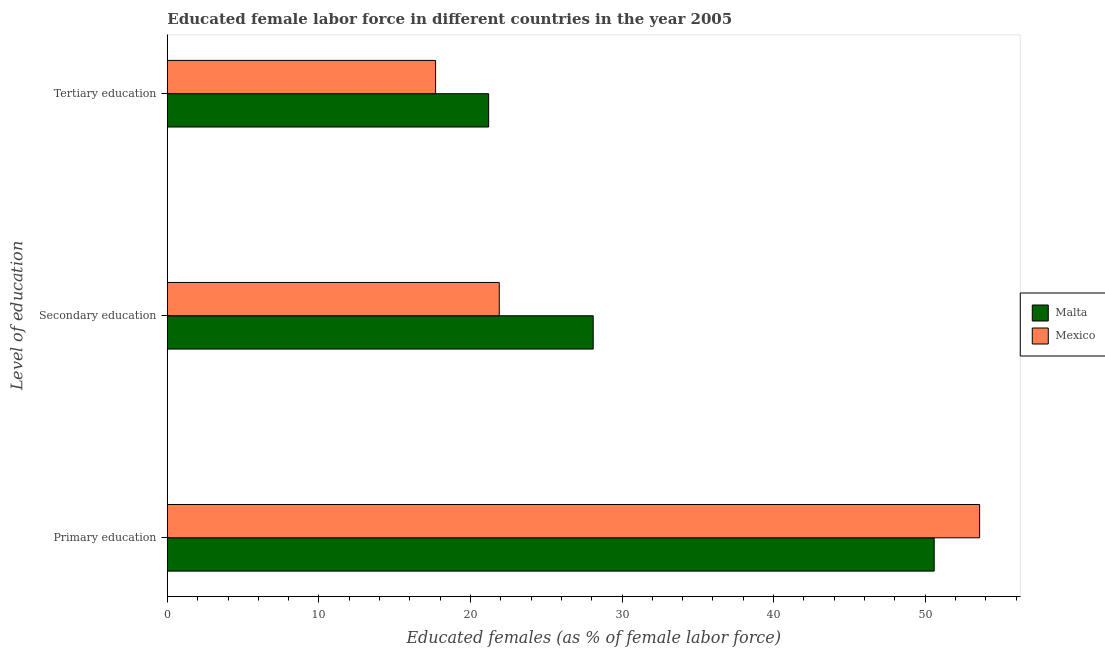How many different coloured bars are there?
Your answer should be compact. 2. Are the number of bars per tick equal to the number of legend labels?
Offer a very short reply. Yes. How many bars are there on the 1st tick from the top?
Your answer should be compact. 2. What is the label of the 1st group of bars from the top?
Your answer should be compact. Tertiary education. What is the percentage of female labor force who received tertiary education in Mexico?
Offer a very short reply. 17.7. Across all countries, what is the maximum percentage of female labor force who received primary education?
Make the answer very short. 53.6. Across all countries, what is the minimum percentage of female labor force who received primary education?
Provide a short and direct response. 50.6. In which country was the percentage of female labor force who received tertiary education maximum?
Provide a succinct answer. Malta. In which country was the percentage of female labor force who received tertiary education minimum?
Give a very brief answer. Mexico. What is the total percentage of female labor force who received tertiary education in the graph?
Your answer should be compact. 38.9. What is the difference between the percentage of female labor force who received secondary education in Mexico and that in Malta?
Your answer should be compact. -6.2. What is the difference between the percentage of female labor force who received secondary education in Mexico and the percentage of female labor force who received primary education in Malta?
Your response must be concise. -28.7. What is the average percentage of female labor force who received primary education per country?
Offer a very short reply. 52.1. What is the difference between the percentage of female labor force who received tertiary education and percentage of female labor force who received secondary education in Malta?
Your answer should be compact. -6.9. What is the ratio of the percentage of female labor force who received secondary education in Mexico to that in Malta?
Offer a very short reply. 0.78. Is the percentage of female labor force who received primary education in Malta less than that in Mexico?
Provide a short and direct response. Yes. Is the difference between the percentage of female labor force who received primary education in Mexico and Malta greater than the difference between the percentage of female labor force who received tertiary education in Mexico and Malta?
Offer a very short reply. Yes. What is the difference between the highest and the lowest percentage of female labor force who received primary education?
Ensure brevity in your answer.  3. Is the sum of the percentage of female labor force who received tertiary education in Mexico and Malta greater than the maximum percentage of female labor force who received secondary education across all countries?
Ensure brevity in your answer.  Yes. What does the 2nd bar from the top in Tertiary education represents?
Make the answer very short. Malta. Is it the case that in every country, the sum of the percentage of female labor force who received primary education and percentage of female labor force who received secondary education is greater than the percentage of female labor force who received tertiary education?
Offer a terse response. Yes. How many bars are there?
Offer a very short reply. 6. Are all the bars in the graph horizontal?
Provide a short and direct response. Yes. Are the values on the major ticks of X-axis written in scientific E-notation?
Ensure brevity in your answer.  No. Where does the legend appear in the graph?
Offer a terse response. Center right. What is the title of the graph?
Offer a terse response. Educated female labor force in different countries in the year 2005. Does "Nicaragua" appear as one of the legend labels in the graph?
Offer a terse response. No. What is the label or title of the X-axis?
Offer a terse response. Educated females (as % of female labor force). What is the label or title of the Y-axis?
Your response must be concise. Level of education. What is the Educated females (as % of female labor force) in Malta in Primary education?
Your response must be concise. 50.6. What is the Educated females (as % of female labor force) of Mexico in Primary education?
Provide a short and direct response. 53.6. What is the Educated females (as % of female labor force) of Malta in Secondary education?
Keep it short and to the point. 28.1. What is the Educated females (as % of female labor force) of Mexico in Secondary education?
Provide a succinct answer. 21.9. What is the Educated females (as % of female labor force) of Malta in Tertiary education?
Your response must be concise. 21.2. What is the Educated females (as % of female labor force) in Mexico in Tertiary education?
Make the answer very short. 17.7. Across all Level of education, what is the maximum Educated females (as % of female labor force) of Malta?
Provide a succinct answer. 50.6. Across all Level of education, what is the maximum Educated females (as % of female labor force) of Mexico?
Make the answer very short. 53.6. Across all Level of education, what is the minimum Educated females (as % of female labor force) in Malta?
Keep it short and to the point. 21.2. Across all Level of education, what is the minimum Educated females (as % of female labor force) in Mexico?
Offer a very short reply. 17.7. What is the total Educated females (as % of female labor force) of Malta in the graph?
Give a very brief answer. 99.9. What is the total Educated females (as % of female labor force) in Mexico in the graph?
Offer a terse response. 93.2. What is the difference between the Educated females (as % of female labor force) of Mexico in Primary education and that in Secondary education?
Make the answer very short. 31.7. What is the difference between the Educated females (as % of female labor force) in Malta in Primary education and that in Tertiary education?
Provide a short and direct response. 29.4. What is the difference between the Educated females (as % of female labor force) of Mexico in Primary education and that in Tertiary education?
Make the answer very short. 35.9. What is the difference between the Educated females (as % of female labor force) in Malta in Secondary education and that in Tertiary education?
Your answer should be compact. 6.9. What is the difference between the Educated females (as % of female labor force) in Mexico in Secondary education and that in Tertiary education?
Offer a terse response. 4.2. What is the difference between the Educated females (as % of female labor force) of Malta in Primary education and the Educated females (as % of female labor force) of Mexico in Secondary education?
Provide a succinct answer. 28.7. What is the difference between the Educated females (as % of female labor force) in Malta in Primary education and the Educated females (as % of female labor force) in Mexico in Tertiary education?
Ensure brevity in your answer.  32.9. What is the difference between the Educated females (as % of female labor force) in Malta in Secondary education and the Educated females (as % of female labor force) in Mexico in Tertiary education?
Ensure brevity in your answer.  10.4. What is the average Educated females (as % of female labor force) of Malta per Level of education?
Offer a terse response. 33.3. What is the average Educated females (as % of female labor force) of Mexico per Level of education?
Your answer should be compact. 31.07. What is the difference between the Educated females (as % of female labor force) of Malta and Educated females (as % of female labor force) of Mexico in Secondary education?
Your answer should be compact. 6.2. What is the difference between the Educated females (as % of female labor force) in Malta and Educated females (as % of female labor force) in Mexico in Tertiary education?
Give a very brief answer. 3.5. What is the ratio of the Educated females (as % of female labor force) in Malta in Primary education to that in Secondary education?
Give a very brief answer. 1.8. What is the ratio of the Educated females (as % of female labor force) in Mexico in Primary education to that in Secondary education?
Offer a terse response. 2.45. What is the ratio of the Educated females (as % of female labor force) of Malta in Primary education to that in Tertiary education?
Give a very brief answer. 2.39. What is the ratio of the Educated females (as % of female labor force) of Mexico in Primary education to that in Tertiary education?
Give a very brief answer. 3.03. What is the ratio of the Educated females (as % of female labor force) of Malta in Secondary education to that in Tertiary education?
Provide a succinct answer. 1.33. What is the ratio of the Educated females (as % of female labor force) in Mexico in Secondary education to that in Tertiary education?
Give a very brief answer. 1.24. What is the difference between the highest and the second highest Educated females (as % of female labor force) of Malta?
Give a very brief answer. 22.5. What is the difference between the highest and the second highest Educated females (as % of female labor force) in Mexico?
Provide a short and direct response. 31.7. What is the difference between the highest and the lowest Educated females (as % of female labor force) of Malta?
Give a very brief answer. 29.4. What is the difference between the highest and the lowest Educated females (as % of female labor force) in Mexico?
Make the answer very short. 35.9. 